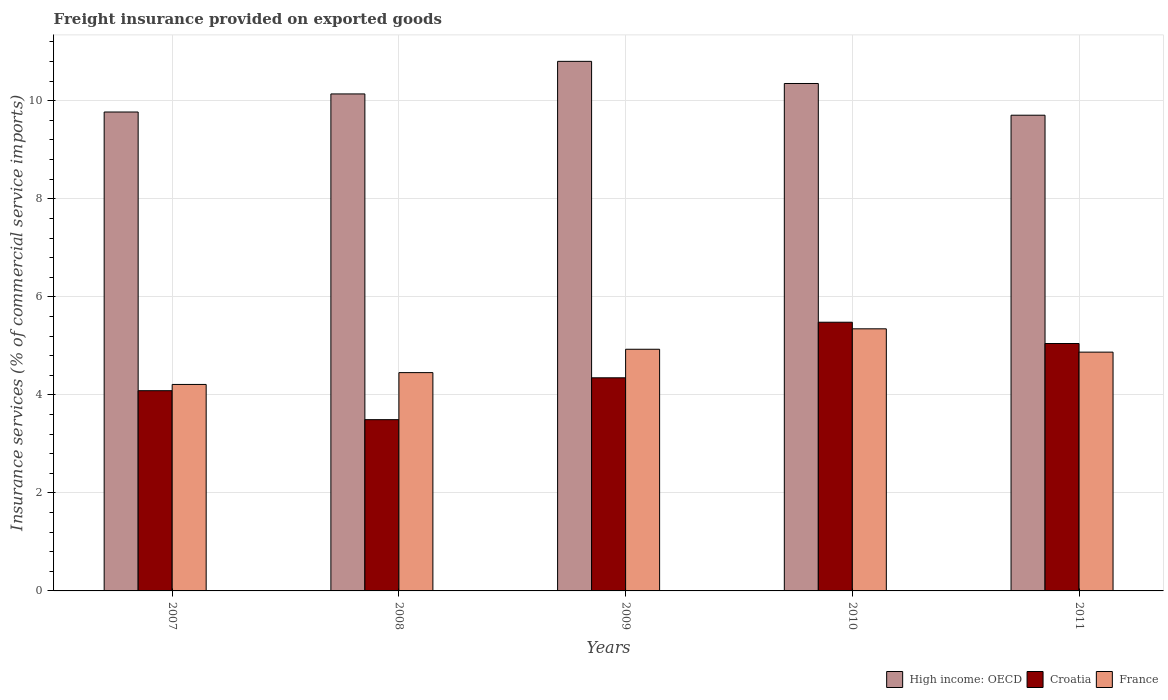How many different coloured bars are there?
Give a very brief answer. 3. Are the number of bars per tick equal to the number of legend labels?
Your response must be concise. Yes. How many bars are there on the 2nd tick from the left?
Keep it short and to the point. 3. In how many cases, is the number of bars for a given year not equal to the number of legend labels?
Make the answer very short. 0. What is the freight insurance provided on exported goods in High income: OECD in 2007?
Keep it short and to the point. 9.77. Across all years, what is the maximum freight insurance provided on exported goods in France?
Make the answer very short. 5.35. Across all years, what is the minimum freight insurance provided on exported goods in France?
Your response must be concise. 4.21. In which year was the freight insurance provided on exported goods in Croatia maximum?
Your answer should be very brief. 2010. What is the total freight insurance provided on exported goods in High income: OECD in the graph?
Offer a terse response. 50.77. What is the difference between the freight insurance provided on exported goods in Croatia in 2009 and that in 2011?
Make the answer very short. -0.7. What is the difference between the freight insurance provided on exported goods in Croatia in 2011 and the freight insurance provided on exported goods in High income: OECD in 2009?
Keep it short and to the point. -5.76. What is the average freight insurance provided on exported goods in France per year?
Give a very brief answer. 4.76. In the year 2008, what is the difference between the freight insurance provided on exported goods in Croatia and freight insurance provided on exported goods in France?
Ensure brevity in your answer.  -0.96. In how many years, is the freight insurance provided on exported goods in Croatia greater than 10 %?
Provide a short and direct response. 0. What is the ratio of the freight insurance provided on exported goods in Croatia in 2008 to that in 2009?
Your answer should be compact. 0.8. Is the difference between the freight insurance provided on exported goods in Croatia in 2007 and 2008 greater than the difference between the freight insurance provided on exported goods in France in 2007 and 2008?
Your answer should be compact. Yes. What is the difference between the highest and the second highest freight insurance provided on exported goods in High income: OECD?
Your response must be concise. 0.45. What is the difference between the highest and the lowest freight insurance provided on exported goods in France?
Provide a short and direct response. 1.13. What does the 3rd bar from the left in 2011 represents?
Provide a succinct answer. France. What does the 2nd bar from the right in 2010 represents?
Offer a terse response. Croatia. How many bars are there?
Ensure brevity in your answer.  15. Are all the bars in the graph horizontal?
Give a very brief answer. No. How many years are there in the graph?
Provide a short and direct response. 5. Are the values on the major ticks of Y-axis written in scientific E-notation?
Your response must be concise. No. Does the graph contain grids?
Make the answer very short. Yes. Where does the legend appear in the graph?
Provide a succinct answer. Bottom right. How many legend labels are there?
Your answer should be very brief. 3. What is the title of the graph?
Ensure brevity in your answer.  Freight insurance provided on exported goods. What is the label or title of the Y-axis?
Give a very brief answer. Insurance services (% of commercial service imports). What is the Insurance services (% of commercial service imports) in High income: OECD in 2007?
Ensure brevity in your answer.  9.77. What is the Insurance services (% of commercial service imports) of Croatia in 2007?
Make the answer very short. 4.09. What is the Insurance services (% of commercial service imports) in France in 2007?
Provide a short and direct response. 4.21. What is the Insurance services (% of commercial service imports) in High income: OECD in 2008?
Provide a short and direct response. 10.14. What is the Insurance services (% of commercial service imports) of Croatia in 2008?
Provide a succinct answer. 3.49. What is the Insurance services (% of commercial service imports) of France in 2008?
Make the answer very short. 4.45. What is the Insurance services (% of commercial service imports) of High income: OECD in 2009?
Give a very brief answer. 10.8. What is the Insurance services (% of commercial service imports) in Croatia in 2009?
Your response must be concise. 4.35. What is the Insurance services (% of commercial service imports) in France in 2009?
Offer a terse response. 4.93. What is the Insurance services (% of commercial service imports) of High income: OECD in 2010?
Keep it short and to the point. 10.35. What is the Insurance services (% of commercial service imports) of Croatia in 2010?
Provide a short and direct response. 5.48. What is the Insurance services (% of commercial service imports) of France in 2010?
Your answer should be very brief. 5.35. What is the Insurance services (% of commercial service imports) in High income: OECD in 2011?
Ensure brevity in your answer.  9.71. What is the Insurance services (% of commercial service imports) in Croatia in 2011?
Offer a very short reply. 5.05. What is the Insurance services (% of commercial service imports) in France in 2011?
Your response must be concise. 4.87. Across all years, what is the maximum Insurance services (% of commercial service imports) in High income: OECD?
Provide a short and direct response. 10.8. Across all years, what is the maximum Insurance services (% of commercial service imports) of Croatia?
Provide a short and direct response. 5.48. Across all years, what is the maximum Insurance services (% of commercial service imports) of France?
Offer a terse response. 5.35. Across all years, what is the minimum Insurance services (% of commercial service imports) of High income: OECD?
Provide a succinct answer. 9.71. Across all years, what is the minimum Insurance services (% of commercial service imports) of Croatia?
Your answer should be compact. 3.49. Across all years, what is the minimum Insurance services (% of commercial service imports) in France?
Give a very brief answer. 4.21. What is the total Insurance services (% of commercial service imports) in High income: OECD in the graph?
Your answer should be compact. 50.77. What is the total Insurance services (% of commercial service imports) of Croatia in the graph?
Offer a terse response. 22.46. What is the total Insurance services (% of commercial service imports) in France in the graph?
Offer a terse response. 23.82. What is the difference between the Insurance services (% of commercial service imports) in High income: OECD in 2007 and that in 2008?
Your answer should be very brief. -0.37. What is the difference between the Insurance services (% of commercial service imports) in Croatia in 2007 and that in 2008?
Your answer should be very brief. 0.59. What is the difference between the Insurance services (% of commercial service imports) in France in 2007 and that in 2008?
Offer a very short reply. -0.24. What is the difference between the Insurance services (% of commercial service imports) in High income: OECD in 2007 and that in 2009?
Your answer should be very brief. -1.03. What is the difference between the Insurance services (% of commercial service imports) of Croatia in 2007 and that in 2009?
Offer a terse response. -0.26. What is the difference between the Insurance services (% of commercial service imports) of France in 2007 and that in 2009?
Your answer should be compact. -0.72. What is the difference between the Insurance services (% of commercial service imports) of High income: OECD in 2007 and that in 2010?
Your response must be concise. -0.58. What is the difference between the Insurance services (% of commercial service imports) in Croatia in 2007 and that in 2010?
Your response must be concise. -1.4. What is the difference between the Insurance services (% of commercial service imports) in France in 2007 and that in 2010?
Keep it short and to the point. -1.13. What is the difference between the Insurance services (% of commercial service imports) in High income: OECD in 2007 and that in 2011?
Make the answer very short. 0.07. What is the difference between the Insurance services (% of commercial service imports) in Croatia in 2007 and that in 2011?
Your answer should be very brief. -0.96. What is the difference between the Insurance services (% of commercial service imports) of France in 2007 and that in 2011?
Make the answer very short. -0.66. What is the difference between the Insurance services (% of commercial service imports) of High income: OECD in 2008 and that in 2009?
Ensure brevity in your answer.  -0.66. What is the difference between the Insurance services (% of commercial service imports) in Croatia in 2008 and that in 2009?
Give a very brief answer. -0.85. What is the difference between the Insurance services (% of commercial service imports) of France in 2008 and that in 2009?
Keep it short and to the point. -0.48. What is the difference between the Insurance services (% of commercial service imports) of High income: OECD in 2008 and that in 2010?
Offer a very short reply. -0.21. What is the difference between the Insurance services (% of commercial service imports) of Croatia in 2008 and that in 2010?
Your answer should be compact. -1.99. What is the difference between the Insurance services (% of commercial service imports) in France in 2008 and that in 2010?
Your answer should be very brief. -0.89. What is the difference between the Insurance services (% of commercial service imports) of High income: OECD in 2008 and that in 2011?
Your answer should be very brief. 0.43. What is the difference between the Insurance services (% of commercial service imports) in Croatia in 2008 and that in 2011?
Make the answer very short. -1.55. What is the difference between the Insurance services (% of commercial service imports) in France in 2008 and that in 2011?
Your answer should be very brief. -0.42. What is the difference between the Insurance services (% of commercial service imports) of High income: OECD in 2009 and that in 2010?
Keep it short and to the point. 0.45. What is the difference between the Insurance services (% of commercial service imports) in Croatia in 2009 and that in 2010?
Keep it short and to the point. -1.13. What is the difference between the Insurance services (% of commercial service imports) of France in 2009 and that in 2010?
Your answer should be compact. -0.42. What is the difference between the Insurance services (% of commercial service imports) of High income: OECD in 2009 and that in 2011?
Offer a terse response. 1.1. What is the difference between the Insurance services (% of commercial service imports) in Croatia in 2009 and that in 2011?
Give a very brief answer. -0.7. What is the difference between the Insurance services (% of commercial service imports) in France in 2009 and that in 2011?
Ensure brevity in your answer.  0.06. What is the difference between the Insurance services (% of commercial service imports) of High income: OECD in 2010 and that in 2011?
Your response must be concise. 0.65. What is the difference between the Insurance services (% of commercial service imports) in Croatia in 2010 and that in 2011?
Keep it short and to the point. 0.43. What is the difference between the Insurance services (% of commercial service imports) of France in 2010 and that in 2011?
Your answer should be compact. 0.48. What is the difference between the Insurance services (% of commercial service imports) of High income: OECD in 2007 and the Insurance services (% of commercial service imports) of Croatia in 2008?
Make the answer very short. 6.28. What is the difference between the Insurance services (% of commercial service imports) of High income: OECD in 2007 and the Insurance services (% of commercial service imports) of France in 2008?
Your answer should be compact. 5.32. What is the difference between the Insurance services (% of commercial service imports) in Croatia in 2007 and the Insurance services (% of commercial service imports) in France in 2008?
Ensure brevity in your answer.  -0.37. What is the difference between the Insurance services (% of commercial service imports) in High income: OECD in 2007 and the Insurance services (% of commercial service imports) in Croatia in 2009?
Offer a terse response. 5.42. What is the difference between the Insurance services (% of commercial service imports) in High income: OECD in 2007 and the Insurance services (% of commercial service imports) in France in 2009?
Keep it short and to the point. 4.84. What is the difference between the Insurance services (% of commercial service imports) in Croatia in 2007 and the Insurance services (% of commercial service imports) in France in 2009?
Your answer should be compact. -0.85. What is the difference between the Insurance services (% of commercial service imports) in High income: OECD in 2007 and the Insurance services (% of commercial service imports) in Croatia in 2010?
Give a very brief answer. 4.29. What is the difference between the Insurance services (% of commercial service imports) of High income: OECD in 2007 and the Insurance services (% of commercial service imports) of France in 2010?
Offer a very short reply. 4.42. What is the difference between the Insurance services (% of commercial service imports) of Croatia in 2007 and the Insurance services (% of commercial service imports) of France in 2010?
Ensure brevity in your answer.  -1.26. What is the difference between the Insurance services (% of commercial service imports) in High income: OECD in 2007 and the Insurance services (% of commercial service imports) in Croatia in 2011?
Give a very brief answer. 4.72. What is the difference between the Insurance services (% of commercial service imports) of High income: OECD in 2007 and the Insurance services (% of commercial service imports) of France in 2011?
Your response must be concise. 4.9. What is the difference between the Insurance services (% of commercial service imports) in Croatia in 2007 and the Insurance services (% of commercial service imports) in France in 2011?
Offer a very short reply. -0.79. What is the difference between the Insurance services (% of commercial service imports) in High income: OECD in 2008 and the Insurance services (% of commercial service imports) in Croatia in 2009?
Provide a short and direct response. 5.79. What is the difference between the Insurance services (% of commercial service imports) of High income: OECD in 2008 and the Insurance services (% of commercial service imports) of France in 2009?
Offer a terse response. 5.21. What is the difference between the Insurance services (% of commercial service imports) in Croatia in 2008 and the Insurance services (% of commercial service imports) in France in 2009?
Make the answer very short. -1.44. What is the difference between the Insurance services (% of commercial service imports) in High income: OECD in 2008 and the Insurance services (% of commercial service imports) in Croatia in 2010?
Your response must be concise. 4.66. What is the difference between the Insurance services (% of commercial service imports) in High income: OECD in 2008 and the Insurance services (% of commercial service imports) in France in 2010?
Offer a terse response. 4.79. What is the difference between the Insurance services (% of commercial service imports) in Croatia in 2008 and the Insurance services (% of commercial service imports) in France in 2010?
Keep it short and to the point. -1.85. What is the difference between the Insurance services (% of commercial service imports) of High income: OECD in 2008 and the Insurance services (% of commercial service imports) of Croatia in 2011?
Provide a succinct answer. 5.09. What is the difference between the Insurance services (% of commercial service imports) of High income: OECD in 2008 and the Insurance services (% of commercial service imports) of France in 2011?
Offer a terse response. 5.27. What is the difference between the Insurance services (% of commercial service imports) in Croatia in 2008 and the Insurance services (% of commercial service imports) in France in 2011?
Provide a short and direct response. -1.38. What is the difference between the Insurance services (% of commercial service imports) in High income: OECD in 2009 and the Insurance services (% of commercial service imports) in Croatia in 2010?
Give a very brief answer. 5.32. What is the difference between the Insurance services (% of commercial service imports) of High income: OECD in 2009 and the Insurance services (% of commercial service imports) of France in 2010?
Your answer should be compact. 5.46. What is the difference between the Insurance services (% of commercial service imports) in Croatia in 2009 and the Insurance services (% of commercial service imports) in France in 2010?
Give a very brief answer. -1. What is the difference between the Insurance services (% of commercial service imports) in High income: OECD in 2009 and the Insurance services (% of commercial service imports) in Croatia in 2011?
Ensure brevity in your answer.  5.76. What is the difference between the Insurance services (% of commercial service imports) of High income: OECD in 2009 and the Insurance services (% of commercial service imports) of France in 2011?
Make the answer very short. 5.93. What is the difference between the Insurance services (% of commercial service imports) in Croatia in 2009 and the Insurance services (% of commercial service imports) in France in 2011?
Provide a succinct answer. -0.52. What is the difference between the Insurance services (% of commercial service imports) in High income: OECD in 2010 and the Insurance services (% of commercial service imports) in Croatia in 2011?
Your answer should be compact. 5.3. What is the difference between the Insurance services (% of commercial service imports) of High income: OECD in 2010 and the Insurance services (% of commercial service imports) of France in 2011?
Ensure brevity in your answer.  5.48. What is the difference between the Insurance services (% of commercial service imports) in Croatia in 2010 and the Insurance services (% of commercial service imports) in France in 2011?
Keep it short and to the point. 0.61. What is the average Insurance services (% of commercial service imports) in High income: OECD per year?
Ensure brevity in your answer.  10.15. What is the average Insurance services (% of commercial service imports) of Croatia per year?
Your response must be concise. 4.49. What is the average Insurance services (% of commercial service imports) in France per year?
Provide a short and direct response. 4.76. In the year 2007, what is the difference between the Insurance services (% of commercial service imports) of High income: OECD and Insurance services (% of commercial service imports) of Croatia?
Your response must be concise. 5.69. In the year 2007, what is the difference between the Insurance services (% of commercial service imports) of High income: OECD and Insurance services (% of commercial service imports) of France?
Provide a succinct answer. 5.56. In the year 2007, what is the difference between the Insurance services (% of commercial service imports) in Croatia and Insurance services (% of commercial service imports) in France?
Give a very brief answer. -0.13. In the year 2008, what is the difference between the Insurance services (% of commercial service imports) of High income: OECD and Insurance services (% of commercial service imports) of Croatia?
Give a very brief answer. 6.65. In the year 2008, what is the difference between the Insurance services (% of commercial service imports) of High income: OECD and Insurance services (% of commercial service imports) of France?
Make the answer very short. 5.69. In the year 2008, what is the difference between the Insurance services (% of commercial service imports) in Croatia and Insurance services (% of commercial service imports) in France?
Make the answer very short. -0.96. In the year 2009, what is the difference between the Insurance services (% of commercial service imports) in High income: OECD and Insurance services (% of commercial service imports) in Croatia?
Ensure brevity in your answer.  6.46. In the year 2009, what is the difference between the Insurance services (% of commercial service imports) of High income: OECD and Insurance services (% of commercial service imports) of France?
Offer a very short reply. 5.87. In the year 2009, what is the difference between the Insurance services (% of commercial service imports) of Croatia and Insurance services (% of commercial service imports) of France?
Your response must be concise. -0.58. In the year 2010, what is the difference between the Insurance services (% of commercial service imports) in High income: OECD and Insurance services (% of commercial service imports) in Croatia?
Provide a short and direct response. 4.87. In the year 2010, what is the difference between the Insurance services (% of commercial service imports) in High income: OECD and Insurance services (% of commercial service imports) in France?
Give a very brief answer. 5.01. In the year 2010, what is the difference between the Insurance services (% of commercial service imports) in Croatia and Insurance services (% of commercial service imports) in France?
Offer a terse response. 0.13. In the year 2011, what is the difference between the Insurance services (% of commercial service imports) of High income: OECD and Insurance services (% of commercial service imports) of Croatia?
Offer a very short reply. 4.66. In the year 2011, what is the difference between the Insurance services (% of commercial service imports) of High income: OECD and Insurance services (% of commercial service imports) of France?
Offer a terse response. 4.83. In the year 2011, what is the difference between the Insurance services (% of commercial service imports) of Croatia and Insurance services (% of commercial service imports) of France?
Provide a short and direct response. 0.18. What is the ratio of the Insurance services (% of commercial service imports) of High income: OECD in 2007 to that in 2008?
Your response must be concise. 0.96. What is the ratio of the Insurance services (% of commercial service imports) in Croatia in 2007 to that in 2008?
Offer a very short reply. 1.17. What is the ratio of the Insurance services (% of commercial service imports) in France in 2007 to that in 2008?
Provide a succinct answer. 0.95. What is the ratio of the Insurance services (% of commercial service imports) of High income: OECD in 2007 to that in 2009?
Offer a terse response. 0.9. What is the ratio of the Insurance services (% of commercial service imports) in Croatia in 2007 to that in 2009?
Keep it short and to the point. 0.94. What is the ratio of the Insurance services (% of commercial service imports) of France in 2007 to that in 2009?
Your answer should be compact. 0.85. What is the ratio of the Insurance services (% of commercial service imports) of High income: OECD in 2007 to that in 2010?
Provide a succinct answer. 0.94. What is the ratio of the Insurance services (% of commercial service imports) of Croatia in 2007 to that in 2010?
Your response must be concise. 0.75. What is the ratio of the Insurance services (% of commercial service imports) in France in 2007 to that in 2010?
Your response must be concise. 0.79. What is the ratio of the Insurance services (% of commercial service imports) of High income: OECD in 2007 to that in 2011?
Provide a succinct answer. 1.01. What is the ratio of the Insurance services (% of commercial service imports) of Croatia in 2007 to that in 2011?
Offer a very short reply. 0.81. What is the ratio of the Insurance services (% of commercial service imports) of France in 2007 to that in 2011?
Make the answer very short. 0.86. What is the ratio of the Insurance services (% of commercial service imports) in High income: OECD in 2008 to that in 2009?
Your response must be concise. 0.94. What is the ratio of the Insurance services (% of commercial service imports) in Croatia in 2008 to that in 2009?
Give a very brief answer. 0.8. What is the ratio of the Insurance services (% of commercial service imports) of France in 2008 to that in 2009?
Keep it short and to the point. 0.9. What is the ratio of the Insurance services (% of commercial service imports) of High income: OECD in 2008 to that in 2010?
Offer a terse response. 0.98. What is the ratio of the Insurance services (% of commercial service imports) in Croatia in 2008 to that in 2010?
Offer a very short reply. 0.64. What is the ratio of the Insurance services (% of commercial service imports) in France in 2008 to that in 2010?
Your answer should be very brief. 0.83. What is the ratio of the Insurance services (% of commercial service imports) of High income: OECD in 2008 to that in 2011?
Provide a succinct answer. 1.04. What is the ratio of the Insurance services (% of commercial service imports) in Croatia in 2008 to that in 2011?
Your answer should be compact. 0.69. What is the ratio of the Insurance services (% of commercial service imports) of France in 2008 to that in 2011?
Make the answer very short. 0.91. What is the ratio of the Insurance services (% of commercial service imports) of High income: OECD in 2009 to that in 2010?
Keep it short and to the point. 1.04. What is the ratio of the Insurance services (% of commercial service imports) in Croatia in 2009 to that in 2010?
Provide a succinct answer. 0.79. What is the ratio of the Insurance services (% of commercial service imports) in France in 2009 to that in 2010?
Keep it short and to the point. 0.92. What is the ratio of the Insurance services (% of commercial service imports) of High income: OECD in 2009 to that in 2011?
Ensure brevity in your answer.  1.11. What is the ratio of the Insurance services (% of commercial service imports) of Croatia in 2009 to that in 2011?
Offer a very short reply. 0.86. What is the ratio of the Insurance services (% of commercial service imports) in France in 2009 to that in 2011?
Your answer should be compact. 1.01. What is the ratio of the Insurance services (% of commercial service imports) of High income: OECD in 2010 to that in 2011?
Give a very brief answer. 1.07. What is the ratio of the Insurance services (% of commercial service imports) of Croatia in 2010 to that in 2011?
Offer a terse response. 1.09. What is the ratio of the Insurance services (% of commercial service imports) of France in 2010 to that in 2011?
Your answer should be compact. 1.1. What is the difference between the highest and the second highest Insurance services (% of commercial service imports) of High income: OECD?
Give a very brief answer. 0.45. What is the difference between the highest and the second highest Insurance services (% of commercial service imports) of Croatia?
Offer a terse response. 0.43. What is the difference between the highest and the second highest Insurance services (% of commercial service imports) of France?
Make the answer very short. 0.42. What is the difference between the highest and the lowest Insurance services (% of commercial service imports) in High income: OECD?
Offer a very short reply. 1.1. What is the difference between the highest and the lowest Insurance services (% of commercial service imports) of Croatia?
Offer a terse response. 1.99. What is the difference between the highest and the lowest Insurance services (% of commercial service imports) in France?
Offer a terse response. 1.13. 